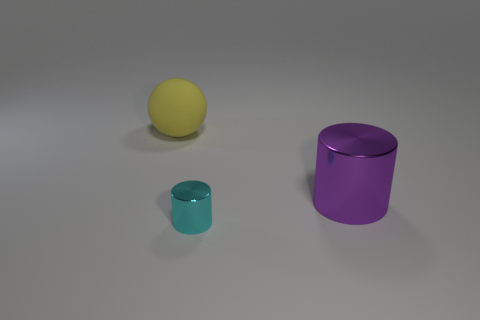Add 2 rubber balls. How many objects exist? 5 Subtract all cylinders. How many objects are left? 1 Subtract all cyan metallic objects. Subtract all tiny blue cylinders. How many objects are left? 2 Add 3 tiny cyan things. How many tiny cyan things are left? 4 Add 1 small cylinders. How many small cylinders exist? 2 Subtract 0 red spheres. How many objects are left? 3 